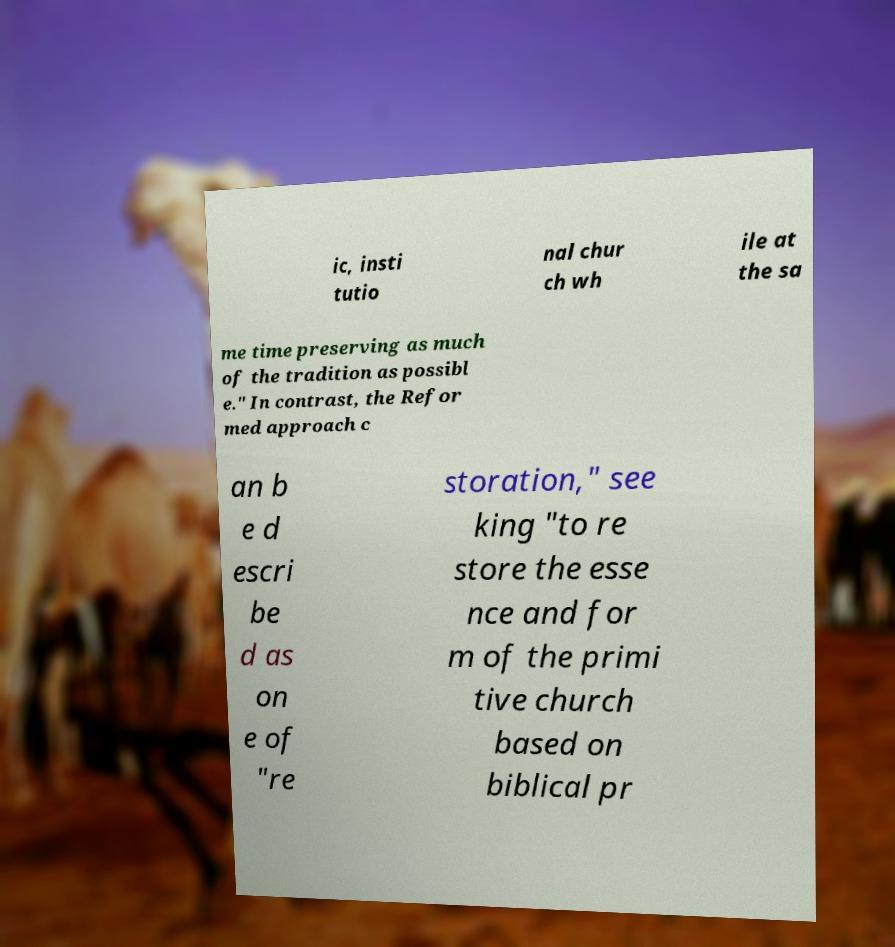Can you accurately transcribe the text from the provided image for me? ic, insti tutio nal chur ch wh ile at the sa me time preserving as much of the tradition as possibl e." In contrast, the Refor med approach c an b e d escri be d as on e of "re storation," see king "to re store the esse nce and for m of the primi tive church based on biblical pr 